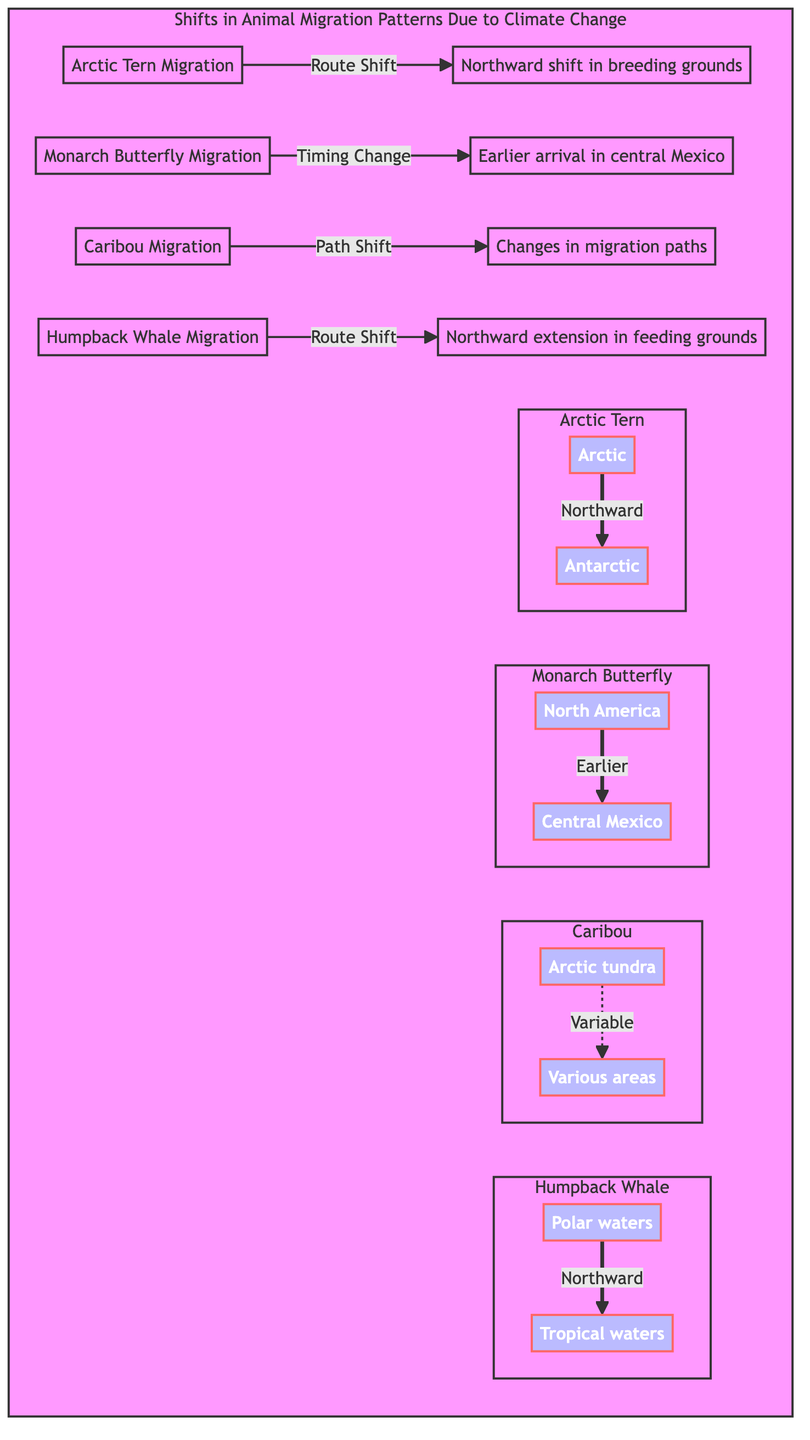What animal species is experiencing a northward shift in breeding grounds? The diagram identifies the Arctic Tern with a direct indication that it is experiencing a northward shift in breeding grounds.
Answer: Arctic Tern Which species has earlier migration timing? The Monarch Butterfly is specified in the diagram as having an earlier arrival in central Mexico, indicating a change in its migration timing.
Answer: Monarch Butterfly What direction does the Humpback Whale migrate towards? According to the diagram, the Humpback Whale migrates from polar waters northward to tropical waters.
Answer: Northward How many animal migrations are illustrated in the diagram? The diagram displays four animal migrations, which are Arctic Tern, Monarch Butterfly, Caribou, and Humpback Whale, making it clear with distinct nodes for each.
Answer: Four What type of shift is indicated for the Caribou migration? The Caribou migration shows a path shift, as indicated by the connection in the diagram detailing the changes in its migration paths.
Answer: Path Shift What do the gradient arrows represent in the diagram? The gradient arrows illustrate the shifts in migration routes and timing for the different animal species, visually representing the movement over recent decades.
Answer: Shifts in migration Which species has its migration route shown as variable? The diagram indicates that the migration for Caribou is variable, as represented by a dashed connection in the subgraph for Caribou.
Answer: Caribou What region do the Arctic Terns migrate to from the Arctic? The diagram shows that Arctic Terns migrate from the Arctic to the Antarctic region, identifying both locations in the subgraph.
Answer: Antarctic What does the notation for the Monarch Butterfly indicate about its migration? The notation indicates an earlier migration timing from North America to Central Mexico, emphasizing the timing change in its migratory behavior.
Answer: Earlier 